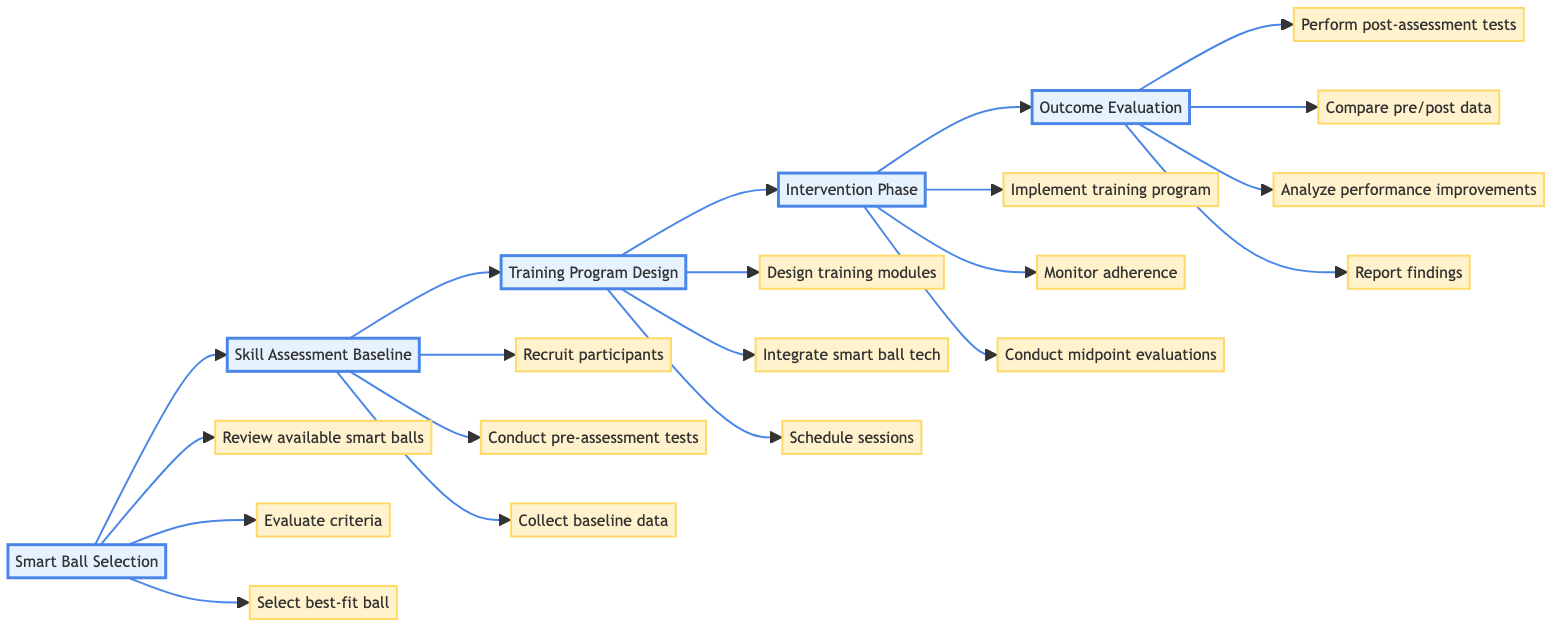What is the first step in the workflow? The diagram clearly indicates that the first step in the workflow is "Smart Ball Selection," as it's the initial node in the horizontal flowchart.
Answer: Smart Ball Selection How many main steps are there in the workflow? By counting the main steps represented in the diagram, there are a total of five distinct steps, starting from "Smart Ball Selection" to "Outcome Evaluation."
Answer: Five What is the third step in the workflow? Following the sequence in the horizontal flowchart, the third step after "Skill Assessment Baseline" is titled "Training Program Design."
Answer: Training Program Design Which step involves the monitoring of participant adherence? In the "Intervention Phase," one of the elements listed is specifically about "Monitoring participant adherence and engagement," which indicates that this occurs during this phase.
Answer: Intervention Phase What action takes place immediately after the "Training Program Design"? The arrow connecting "Training Program Design" to the next step points to "Intervention Phase," indicating that the training program is implemented immediately afterward.
Answer: Intervention Phase Which step includes statistical analysis? The "Outcome Evaluation" step contains the element "Statistical analysis - significance of performance improvements," which specifies the analysis is part of evaluating the intervention outcome.
Answer: Outcome Evaluation What does the "Post-assessment tests" entail? Under the "Outcome Evaluation" step, it specifies "Post-assessment tests - repeated dribbling, passing, shooting accuracy," highlighting what is evaluated after the intervention.
Answer: Post-assessment tests Which elements are part of "Smart Ball Selection"? Within the "Smart Ball Selection" step, the elements listed are "Review of available smart balls," "Evaluation criteria," and "Selection of best-fit smart ball," all of which relate to this step.
Answer: Review of available smart balls, Evaluation criteria, Selection of best-fit smart ball What is designed during the "Training Program Design" phase? The elements in this phase include "Customized training modules," "Integration of smart ball technology," and "Scheduling," indicating that these specific aspects are designed in this phase.
Answer: Customized training modules, Integration of smart ball technology, Scheduling 